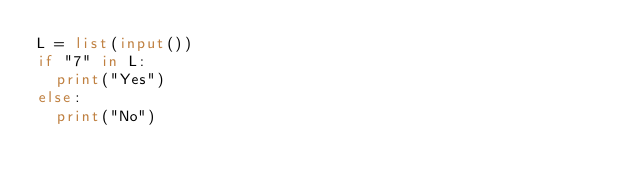Convert code to text. <code><loc_0><loc_0><loc_500><loc_500><_Python_>L = list(input())
if "7" in L:
  print("Yes")
else:
  print("No")</code> 